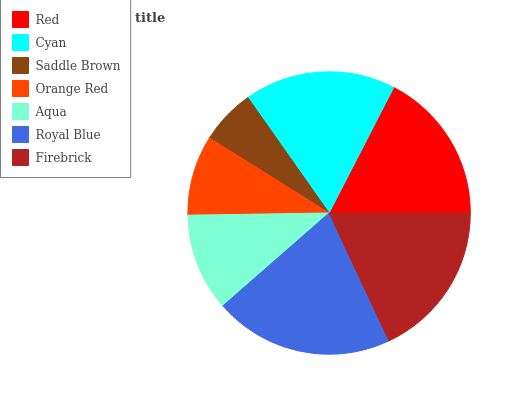Is Saddle Brown the minimum?
Answer yes or no. Yes. Is Royal Blue the maximum?
Answer yes or no. Yes. Is Cyan the minimum?
Answer yes or no. No. Is Cyan the maximum?
Answer yes or no. No. Is Red greater than Cyan?
Answer yes or no. Yes. Is Cyan less than Red?
Answer yes or no. Yes. Is Cyan greater than Red?
Answer yes or no. No. Is Red less than Cyan?
Answer yes or no. No. Is Cyan the high median?
Answer yes or no. Yes. Is Cyan the low median?
Answer yes or no. Yes. Is Orange Red the high median?
Answer yes or no. No. Is Saddle Brown the low median?
Answer yes or no. No. 